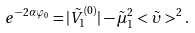<formula> <loc_0><loc_0><loc_500><loc_500>e ^ { - 2 \alpha \varphi _ { 0 } } = | \tilde { V } _ { 1 } ^ { ( 0 ) } | - \tilde { \mu } _ { 1 } ^ { 2 } < \tilde { \upsilon } > ^ { 2 } .</formula> 